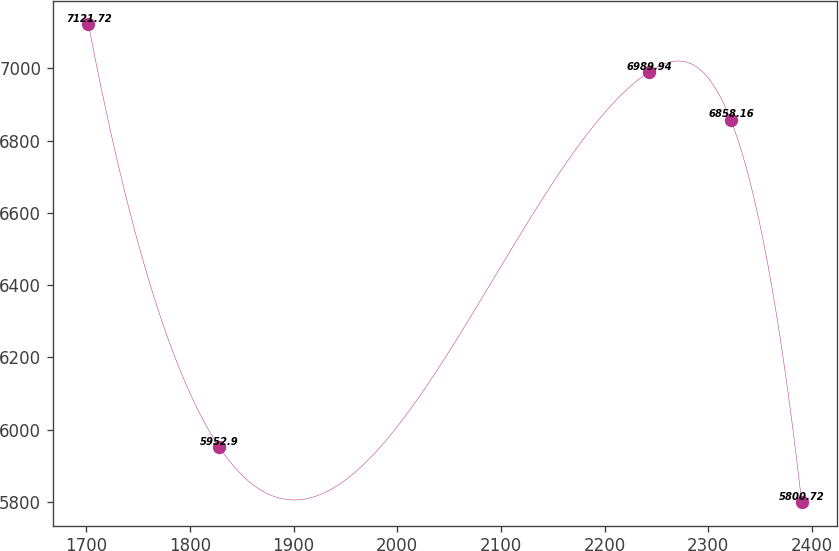Convert chart to OTSL. <chart><loc_0><loc_0><loc_500><loc_500><line_chart><ecel><fcel>Unnamed: 1<nl><fcel>1702.01<fcel>7121.72<nl><fcel>1828.01<fcel>5952.9<nl><fcel>2242.77<fcel>6989.94<nl><fcel>2321.61<fcel>6858.16<nl><fcel>2390.15<fcel>5800.72<nl></chart> 